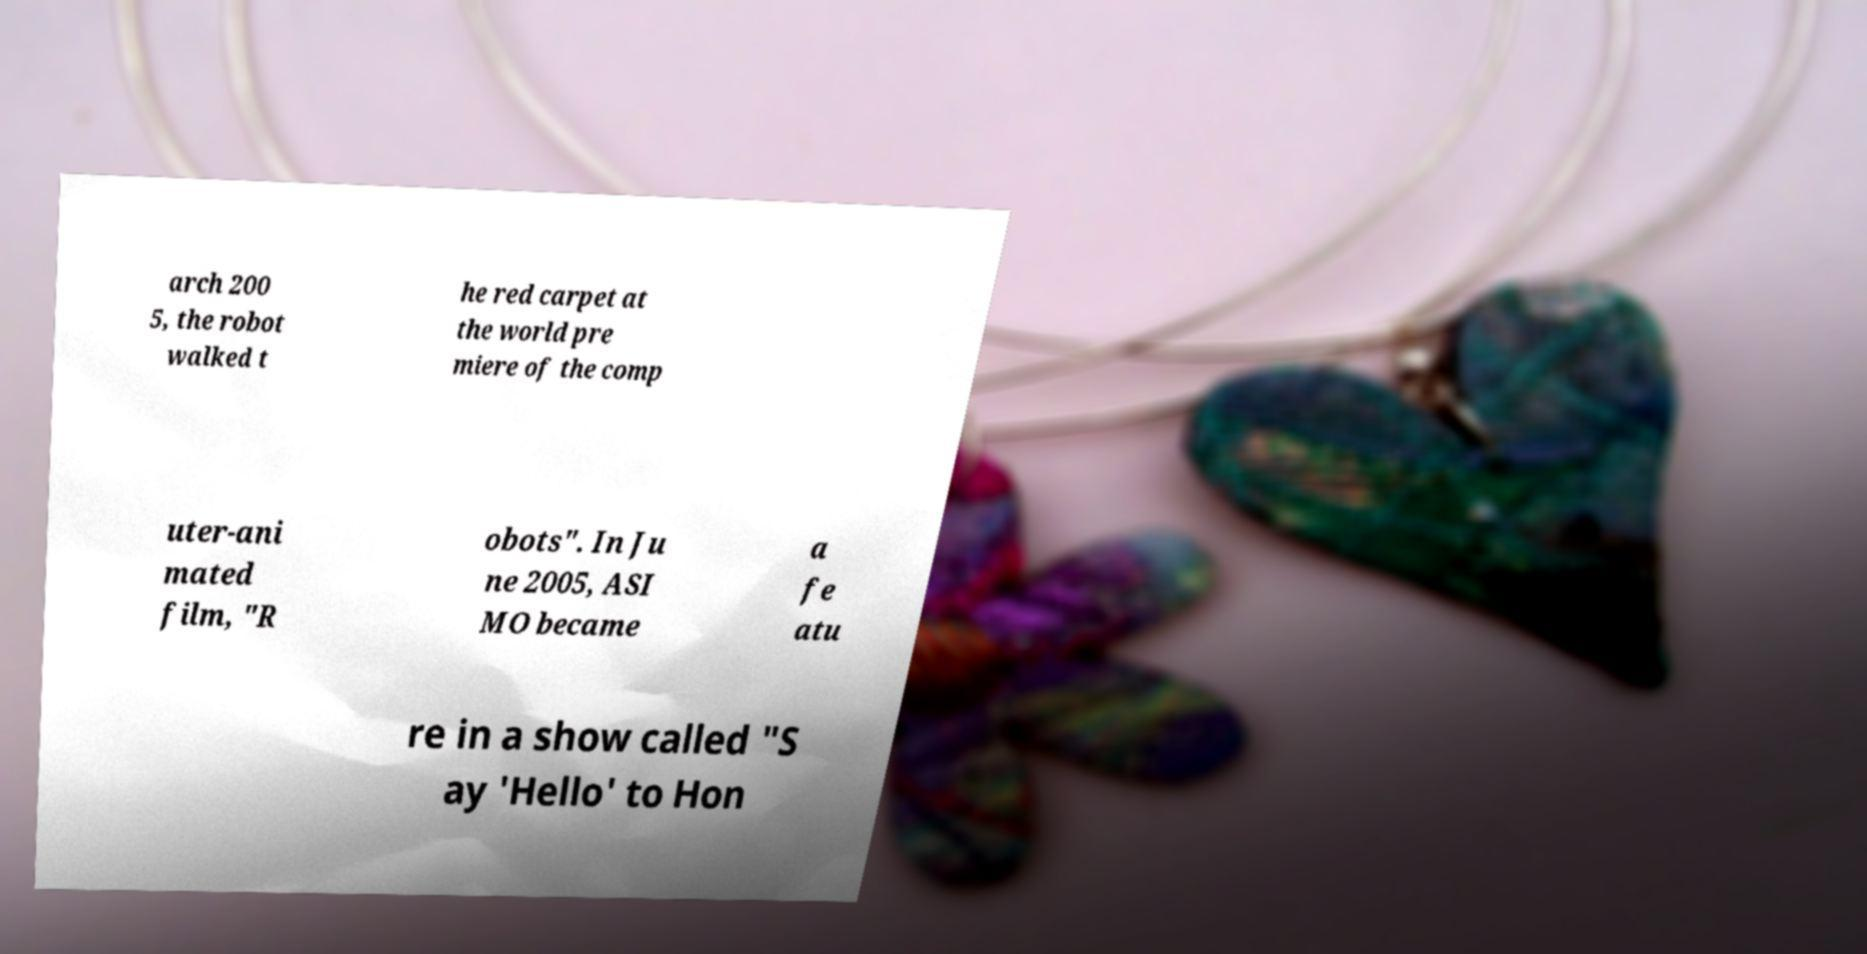For documentation purposes, I need the text within this image transcribed. Could you provide that? arch 200 5, the robot walked t he red carpet at the world pre miere of the comp uter-ani mated film, "R obots". In Ju ne 2005, ASI MO became a fe atu re in a show called "S ay 'Hello' to Hon 